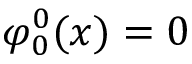<formula> <loc_0><loc_0><loc_500><loc_500>\varphi _ { 0 } ^ { 0 } ( x ) = 0</formula> 